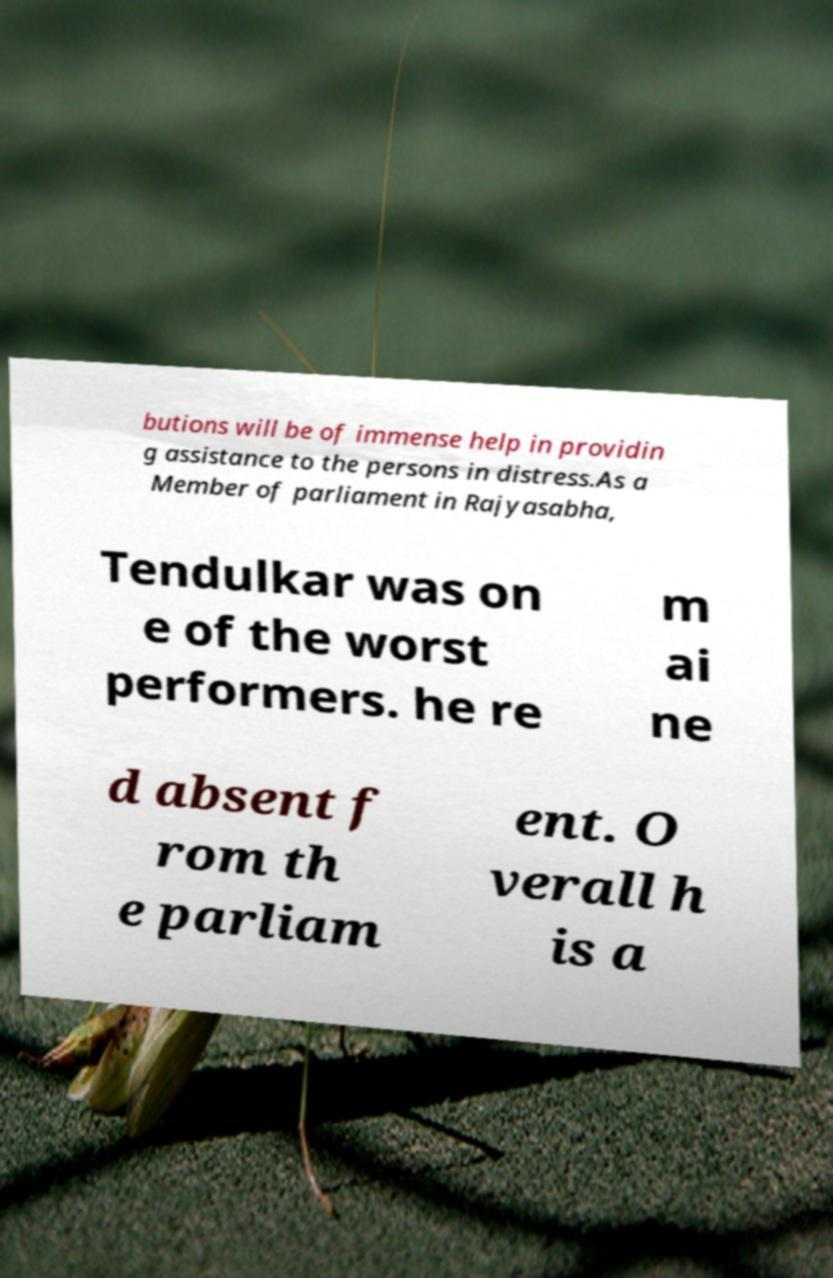Please identify and transcribe the text found in this image. butions will be of immense help in providin g assistance to the persons in distress.As a Member of parliament in Rajyasabha, Tendulkar was on e of the worst performers. he re m ai ne d absent f rom th e parliam ent. O verall h is a 